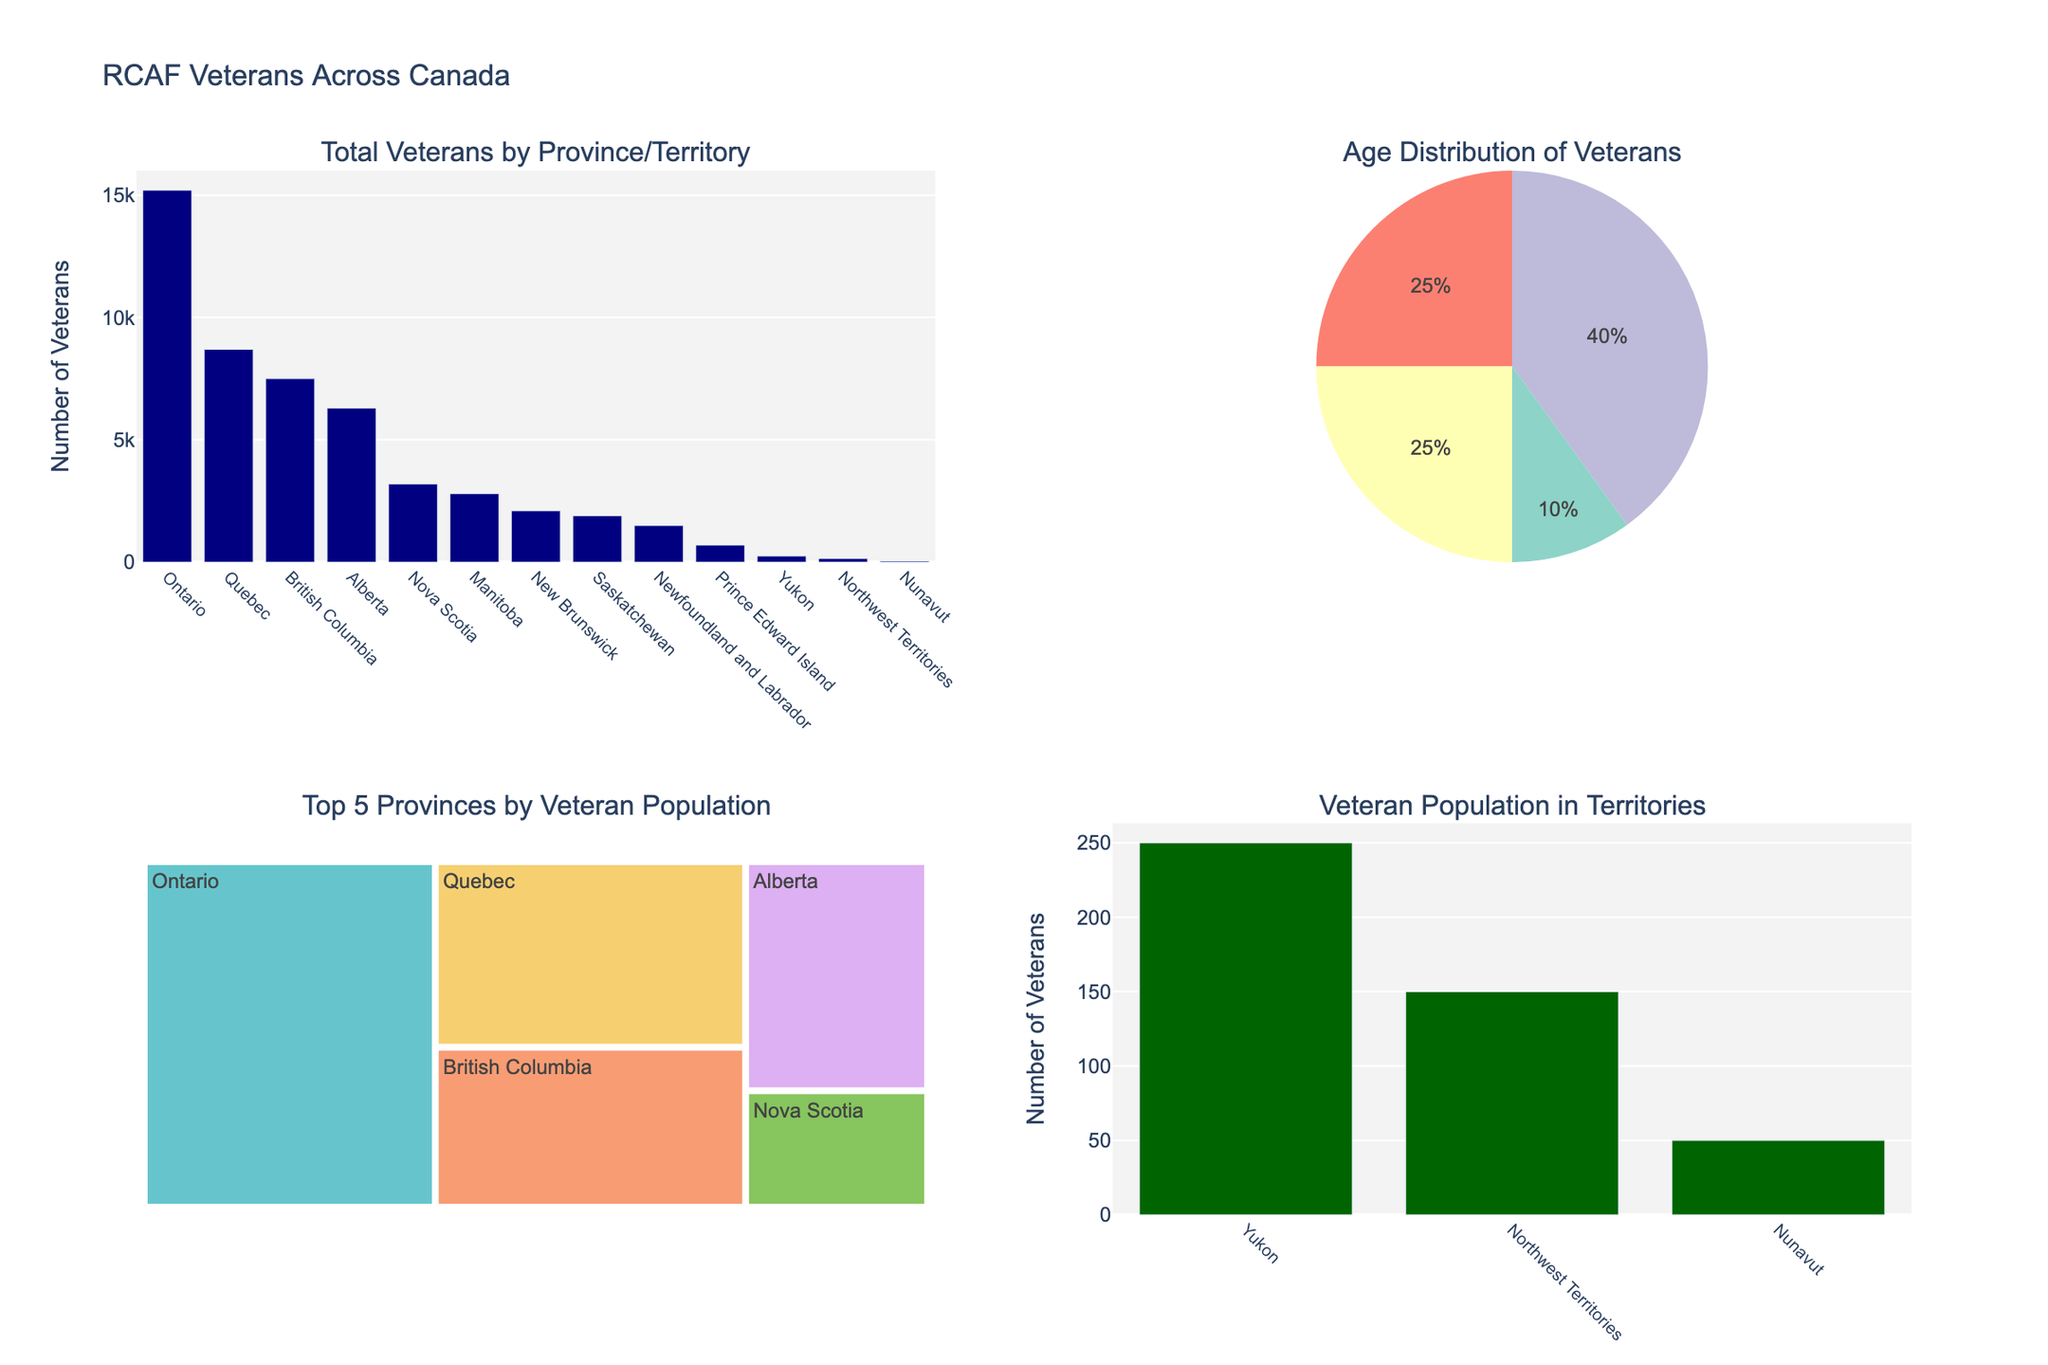What is the total number of RCAF veterans in Ontario? The figure has a bar chart showcasing the total number of veterans in each province and territory. By looking at the bar representing Ontario, it is labeled and shows the height indicating 15,200 veterans.
Answer: 15,200 What percentage of veterans are aged 50-64? The total number of veterans in the pie chart is the sum of the values for each age group. The age group 50-64 is one category in the pie chart legend. Calculate the percentage as (number of veterans aged 50-64 / total number of veterans) * 100% = (16,211 / 48,350) * 100% = 33.53%.
Answer: 33.53% Which province has the second-highest number of RCAF veterans? From the bar chart of total veterans by province, Quebec has the second-highest bar after Ontario.
Answer: Quebec How does the veteran population in Nova Scotia compare with Saskatchewan? Examine the heights of the bars for Nova Scotia and Saskatchewan on the bar chart. Nova Scotia has 3,200 veterans, while Saskatchewan has 1,900 veterans.
Answer: Nova Scotia has more veterans What is the age group distribution in Quebec? Refer to the age distribution for each age group column in Quebec's row on the pie chart, reflecting: Under 50 (870), 50-64 (2,175), 65-79 (3,480), and 80+ (2,175).
Answer: Under 50: 870, 50-64: 2,175, 65-79: 3,480, 80+: 2,175 Which provinces are included in the top five for veteran population? The treemap in the bottom-left subplot lists the five provinces with the largest veteran populations: Ontario, Quebec, British Columbia, Alberta, and Nova Scotia.
Answer: Ontario, Quebec, British Columbia, Alberta, Nova Scotia How many veterans reside in the territories? The bar chart for territories includes the total number of veterans in Yukon, Northwest Territories, and Nunavut. Add them together: 250 (Yukon) + 150 (Northwest Territories) + 50 (Nunavut) = 450.
Answer: 450 What is the title of the entire figure? The title is displayed at the top of the figure, and it reads: "RCAF Veterans Across Canada."
Answer: RCAF Veterans Across Canada Which age group has the least number of veterans? The pie chart shows the total counts for each age group across Canada. The smallest slice represents ages Under 50 with a total of 4,815 veterans.
Answer: Under 50 